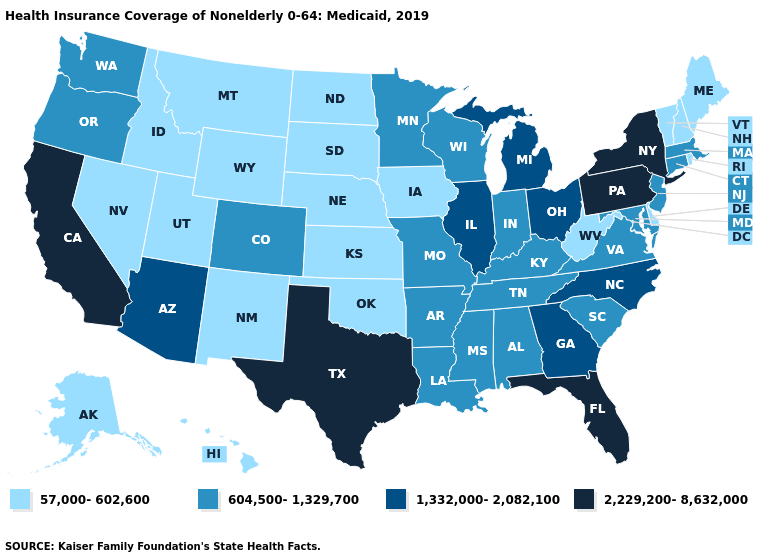Name the states that have a value in the range 2,229,200-8,632,000?
Write a very short answer. California, Florida, New York, Pennsylvania, Texas. Does Arizona have the same value as Utah?
Give a very brief answer. No. What is the value of Hawaii?
Write a very short answer. 57,000-602,600. Name the states that have a value in the range 57,000-602,600?
Give a very brief answer. Alaska, Delaware, Hawaii, Idaho, Iowa, Kansas, Maine, Montana, Nebraska, Nevada, New Hampshire, New Mexico, North Dakota, Oklahoma, Rhode Island, South Dakota, Utah, Vermont, West Virginia, Wyoming. Does Virginia have the highest value in the USA?
Give a very brief answer. No. Does West Virginia have the lowest value in the South?
Write a very short answer. Yes. Name the states that have a value in the range 57,000-602,600?
Keep it brief. Alaska, Delaware, Hawaii, Idaho, Iowa, Kansas, Maine, Montana, Nebraska, Nevada, New Hampshire, New Mexico, North Dakota, Oklahoma, Rhode Island, South Dakota, Utah, Vermont, West Virginia, Wyoming. What is the value of Missouri?
Be succinct. 604,500-1,329,700. What is the lowest value in the USA?
Give a very brief answer. 57,000-602,600. Does South Dakota have the lowest value in the USA?
Keep it brief. Yes. What is the highest value in the USA?
Answer briefly. 2,229,200-8,632,000. Name the states that have a value in the range 57,000-602,600?
Short answer required. Alaska, Delaware, Hawaii, Idaho, Iowa, Kansas, Maine, Montana, Nebraska, Nevada, New Hampshire, New Mexico, North Dakota, Oklahoma, Rhode Island, South Dakota, Utah, Vermont, West Virginia, Wyoming. What is the lowest value in the USA?
Concise answer only. 57,000-602,600. Does Oklahoma have the lowest value in the South?
Answer briefly. Yes. 